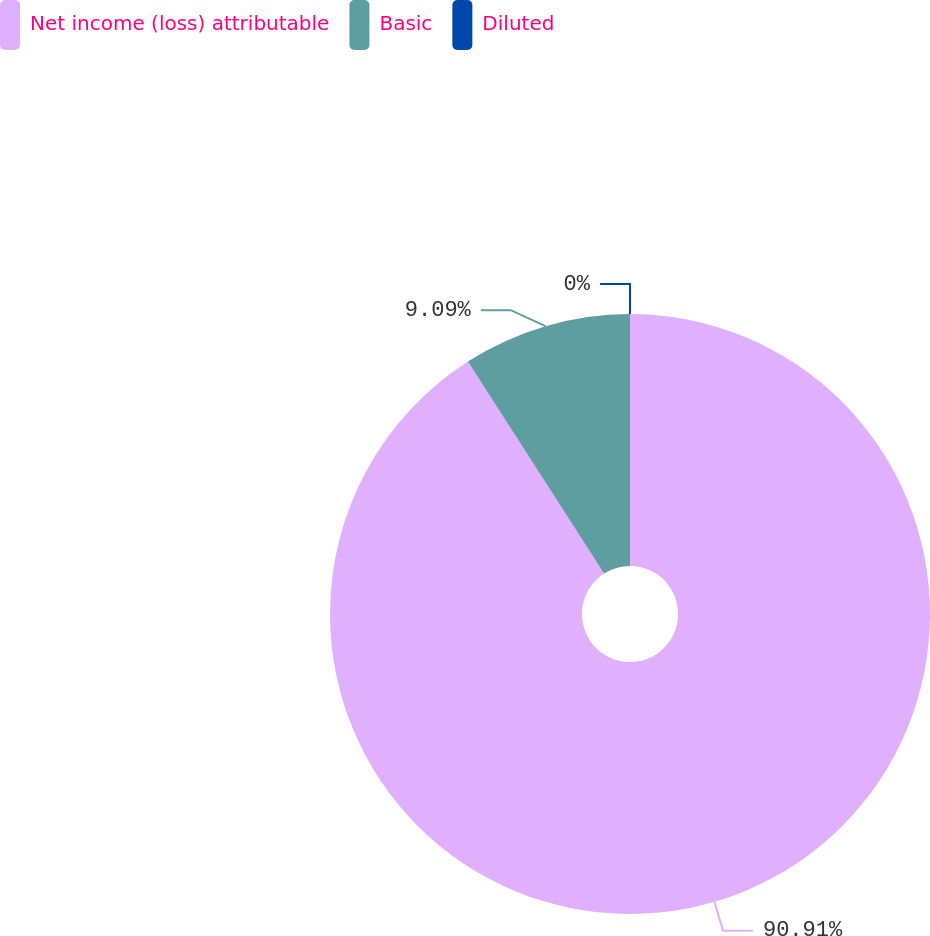<chart> <loc_0><loc_0><loc_500><loc_500><pie_chart><fcel>Net income (loss) attributable<fcel>Basic<fcel>Diluted<nl><fcel>90.91%<fcel>9.09%<fcel>0.0%<nl></chart> 